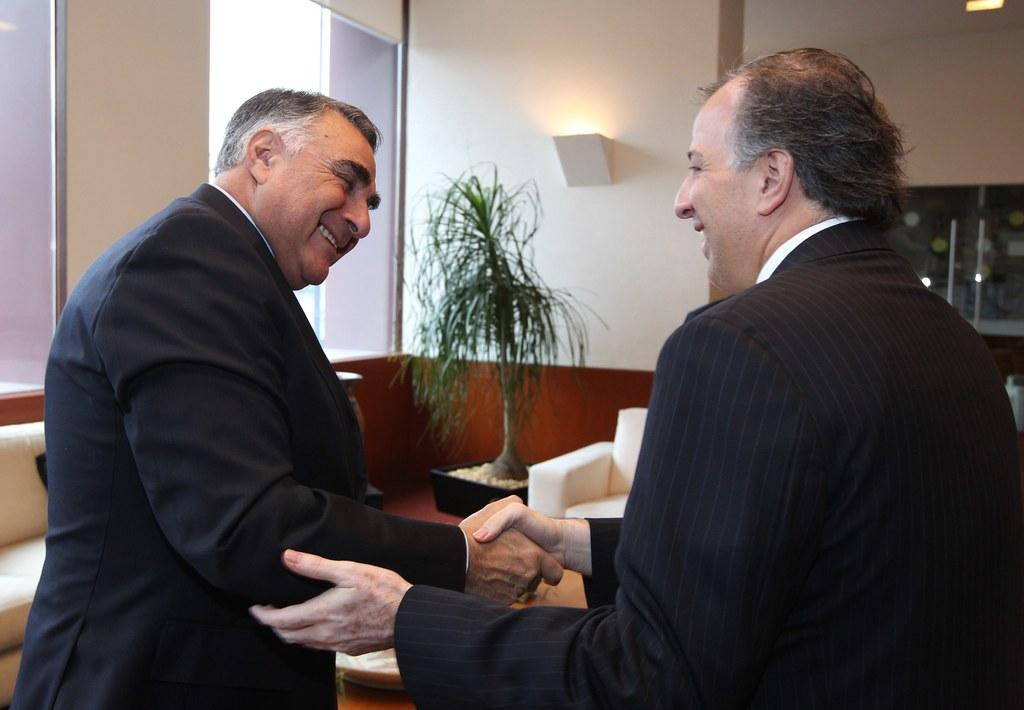How many men are in the image? There are two men standing in the center of the image. What is the facial expression of the men? The men are smiling. What can be seen in the background of the image? There is a wall, a plant, a pot, a couch, lights, a door, glass, and a handle in the background of the image. What type of flowers are being held by the men in the image? There are no flowers visible in the image; the men are not holding any flowers. What is the relation between the two men in the image? The provided facts do not give any information about the relationship between the two men, so we cannot determine their relation from the image. 